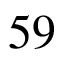<formula> <loc_0><loc_0><loc_500><loc_500>5 9</formula> 